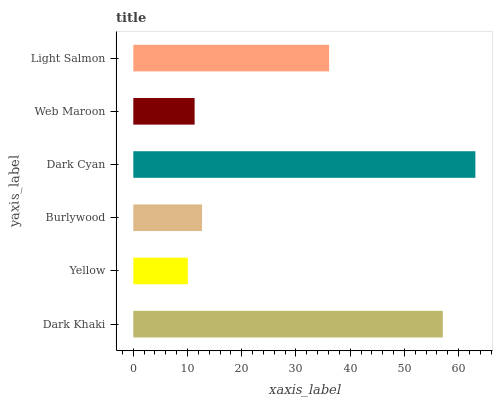Is Yellow the minimum?
Answer yes or no. Yes. Is Dark Cyan the maximum?
Answer yes or no. Yes. Is Burlywood the minimum?
Answer yes or no. No. Is Burlywood the maximum?
Answer yes or no. No. Is Burlywood greater than Yellow?
Answer yes or no. Yes. Is Yellow less than Burlywood?
Answer yes or no. Yes. Is Yellow greater than Burlywood?
Answer yes or no. No. Is Burlywood less than Yellow?
Answer yes or no. No. Is Light Salmon the high median?
Answer yes or no. Yes. Is Burlywood the low median?
Answer yes or no. Yes. Is Burlywood the high median?
Answer yes or no. No. Is Yellow the low median?
Answer yes or no. No. 